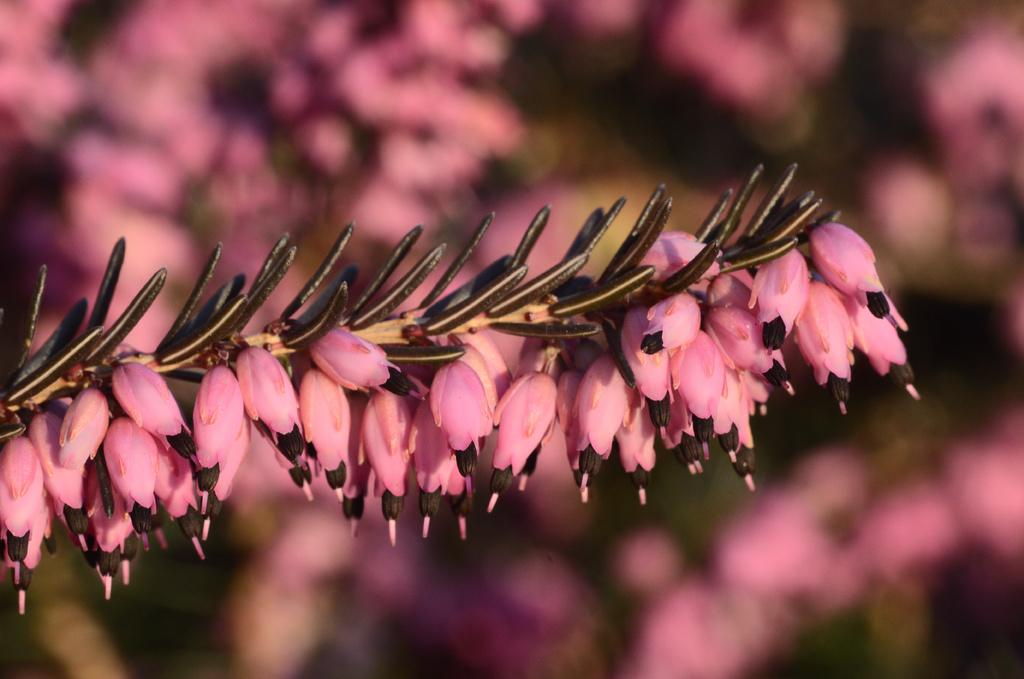What type of living organisms are in the image? There are flowers in the image. What color are the flowers in the image? The flowers are in pink color. What other stage of growth can be seen in the image? There are buds in the image. What color are the buds in the image? The buds are in brown color. What type of circle can be seen in the image? There is no circle present in the image. How many books are visible in the image? There are no books present in the image. 